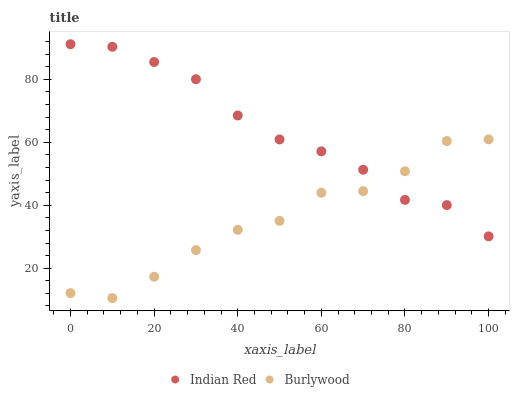Does Burlywood have the minimum area under the curve?
Answer yes or no. Yes. Does Indian Red have the maximum area under the curve?
Answer yes or no. Yes. Does Indian Red have the minimum area under the curve?
Answer yes or no. No. Is Indian Red the smoothest?
Answer yes or no. Yes. Is Burlywood the roughest?
Answer yes or no. Yes. Is Indian Red the roughest?
Answer yes or no. No. Does Burlywood have the lowest value?
Answer yes or no. Yes. Does Indian Red have the lowest value?
Answer yes or no. No. Does Indian Red have the highest value?
Answer yes or no. Yes. Does Indian Red intersect Burlywood?
Answer yes or no. Yes. Is Indian Red less than Burlywood?
Answer yes or no. No. Is Indian Red greater than Burlywood?
Answer yes or no. No. 